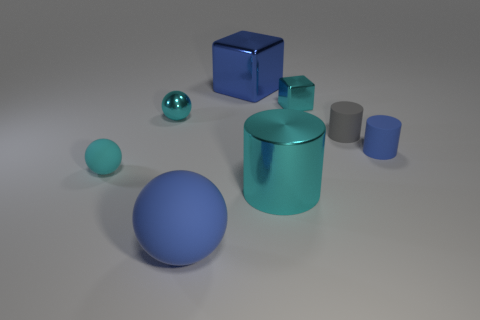Is the number of large metallic things on the left side of the small cyan shiny ball the same as the number of large blocks?
Offer a terse response. No. There is a cyan shiny thing left of the large blue ball; how big is it?
Provide a short and direct response. Small. What number of small yellow things have the same shape as the gray object?
Your response must be concise. 0. There is a thing that is behind the blue matte sphere and in front of the small cyan matte thing; what material is it made of?
Your answer should be compact. Metal. Is the big cyan object made of the same material as the tiny block?
Offer a very short reply. Yes. How many cyan metallic balls are there?
Offer a very short reply. 1. There is a matte ball in front of the cyan thing in front of the tiny rubber thing that is on the left side of the big blue metal cube; what color is it?
Provide a succinct answer. Blue. Is the color of the metal cylinder the same as the tiny block?
Make the answer very short. Yes. How many objects are both in front of the small gray thing and behind the large cyan metallic thing?
Provide a short and direct response. 2. What number of matte objects are either blue balls or big green objects?
Give a very brief answer. 1. 